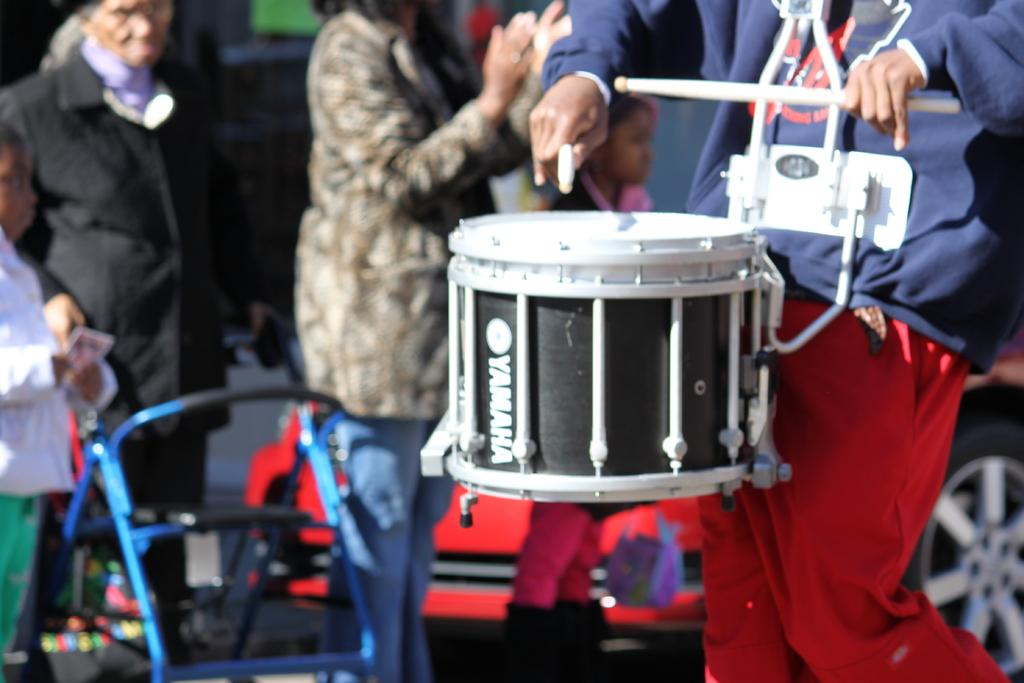What is the person in the image doing? The person is playing drums. What color is the t-shirt the person is wearing? The person is wearing a blue t-shirt. What color are the pants the person is wearing? The person is wearing red pants. Are there any other people in the image? Yes, there are people standing behind the person playing drums. What can be seen in the background of the image? There is a red car in the background of the image. Can you see any mice running around in the image? No, there are no mice present in the image. Is there a drawer visible in the image? No, there is no drawer present in the image. 